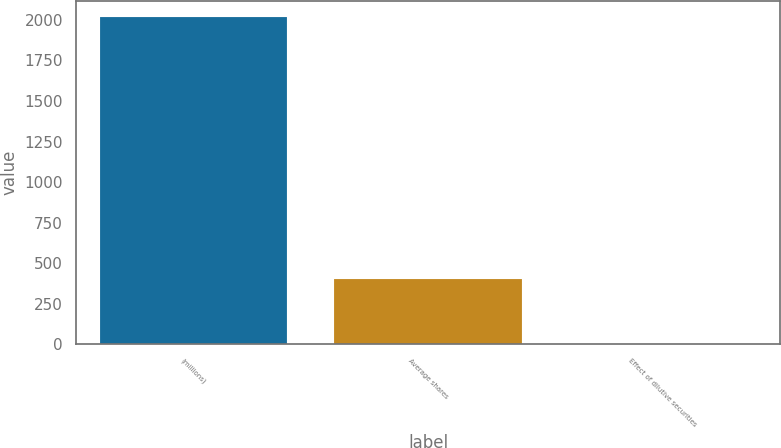<chart> <loc_0><loc_0><loc_500><loc_500><bar_chart><fcel>(millions)<fcel>Average shares<fcel>Effect of dilutive securities<nl><fcel>2014<fcel>403.68<fcel>1.1<nl></chart> 